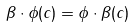Convert formula to latex. <formula><loc_0><loc_0><loc_500><loc_500>\beta \cdot \phi ( c ) = \phi \cdot \beta ( c )</formula> 